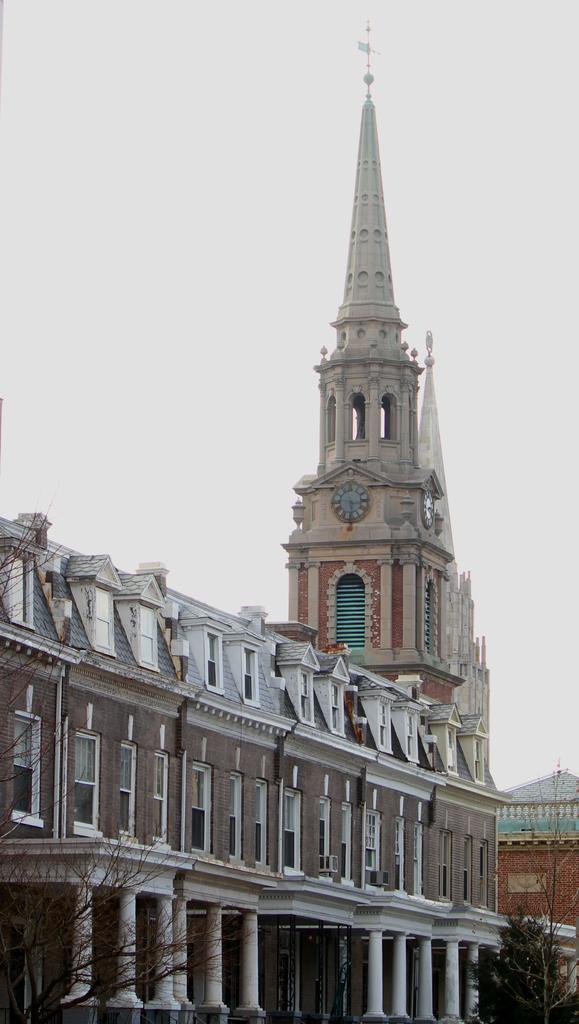Describe this image in one or two sentences. At the bottom of the picture, we see buildings and trees and behind that, we see a steeple. At the top of the picture, we see the sky and this picture is clicked outside the city. 